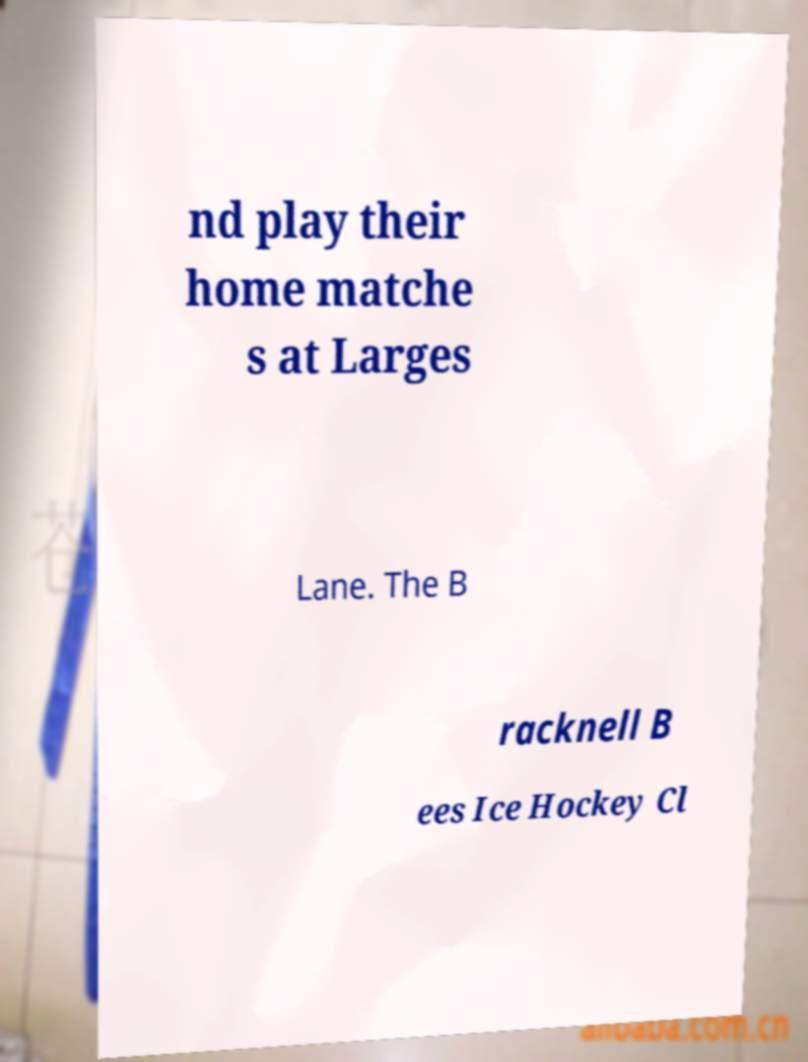Could you assist in decoding the text presented in this image and type it out clearly? nd play their home matche s at Larges Lane. The B racknell B ees Ice Hockey Cl 